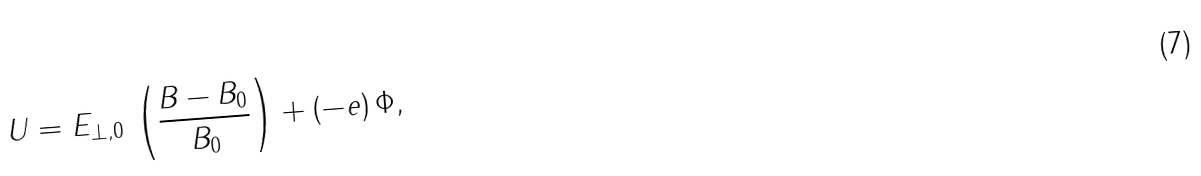Convert formula to latex. <formula><loc_0><loc_0><loc_500><loc_500>U = E _ { \perp , 0 } \, \left ( \frac { B - B _ { 0 } } { B _ { 0 } } \right ) + \left ( - e \right ) \Phi ,</formula> 